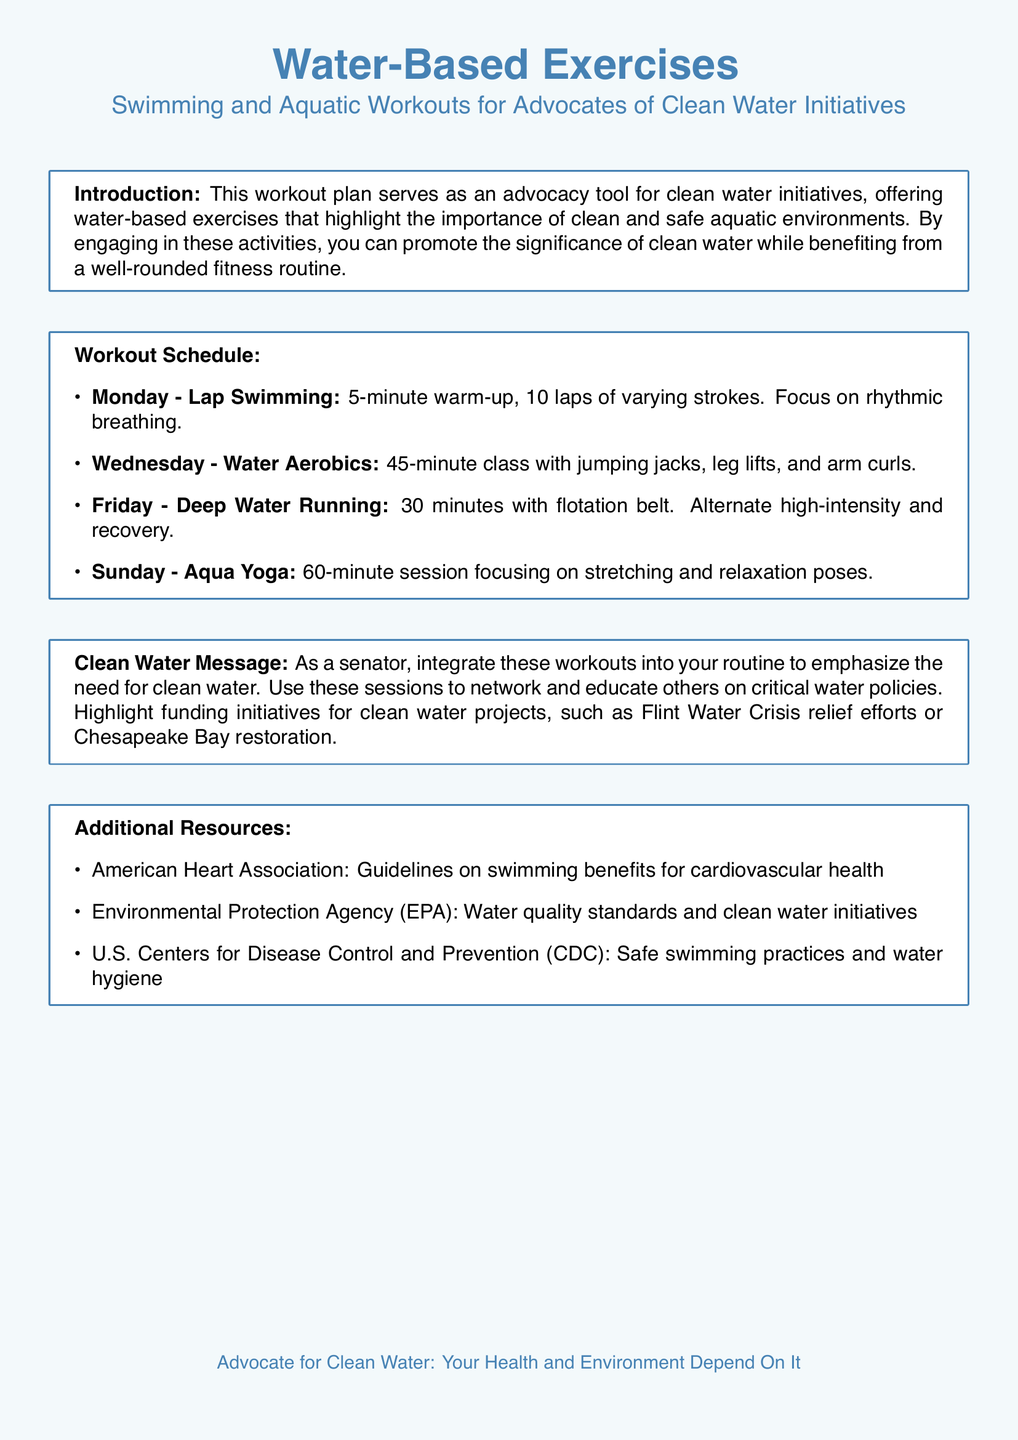What is the primary focus of the workout plan? The primary focus is to serve as an advocacy tool for clean water initiatives.
Answer: advocacy tool for clean water initiatives How long is the deep water running session? The document states that the deep water running session lasts for 30 minutes.
Answer: 30 minutes What day is Aqua Yoga scheduled in the workout plan? The document indicates that Aqua Yoga is scheduled for Sunday.
Answer: Sunday What type of exercise is included on Wednesdays? Wednesday features a 45-minute class with water aerobics exercises.
Answer: Water Aerobics What is emphasized during the lap swimming on Monday? The document emphasizes focusing on rhythmic breathing during lap swimming.
Answer: rhythmic breathing Name one organization referenced for additional resources. The document mentions the American Heart Association as an additional resource.
Answer: American Heart Association What kind of message should be integrated into the workouts? The document suggests integrating a clean water message into the workouts.
Answer: clean water message How many laps are suggested in the Monday lap swimming workout? The workout plan suggests completing 10 laps during the swimming session.
Answer: 10 laps 